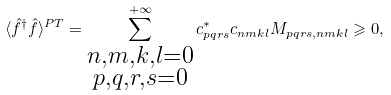<formula> <loc_0><loc_0><loc_500><loc_500>\langle \hat { f } ^ { \dagger } \hat { f } \rangle ^ { P T } = \sum ^ { + \infty } _ { \substack { n , m , k , l = 0 \\ p , q , r , s = 0 } } c ^ { * } _ { p q r s } c _ { n m k l } M _ { p q r s , n m k l } \geqslant 0 ,</formula> 